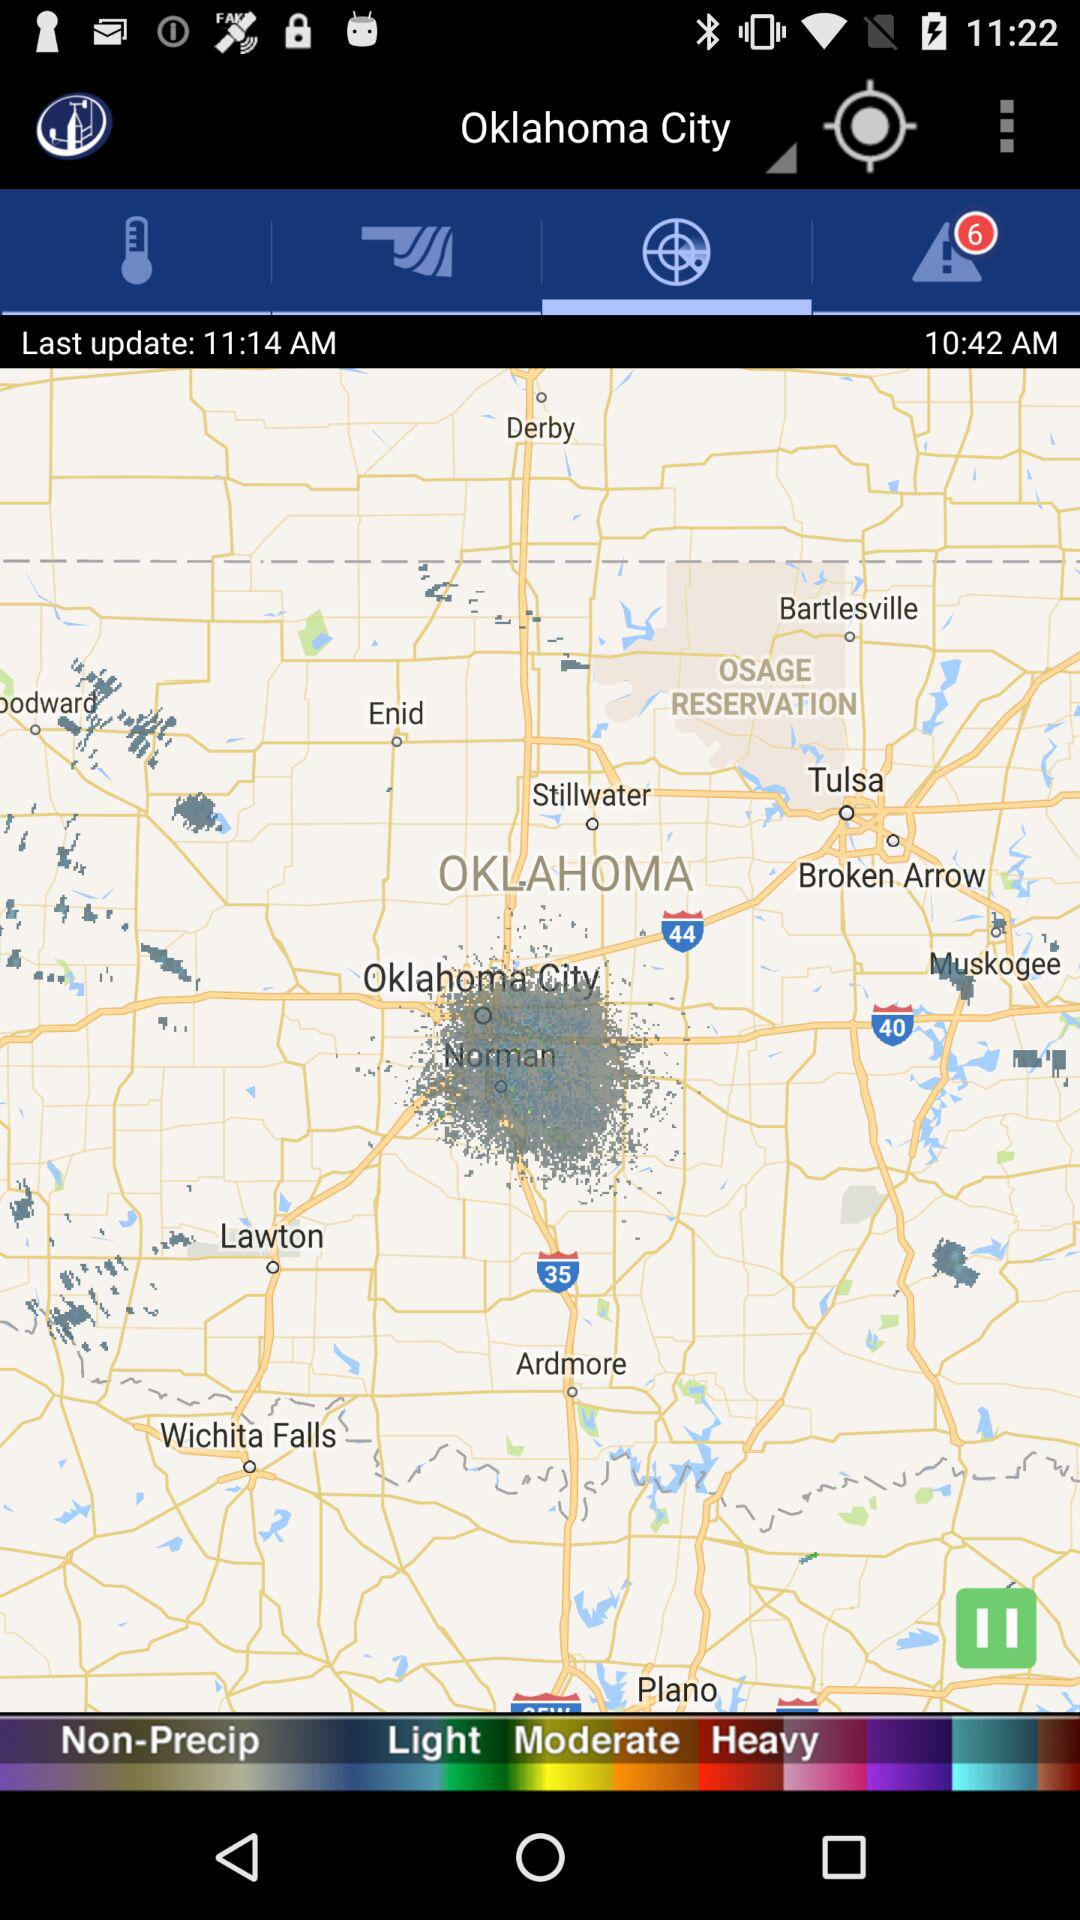What city is located on the map? The city that is located on the map is Oklahoma City. 